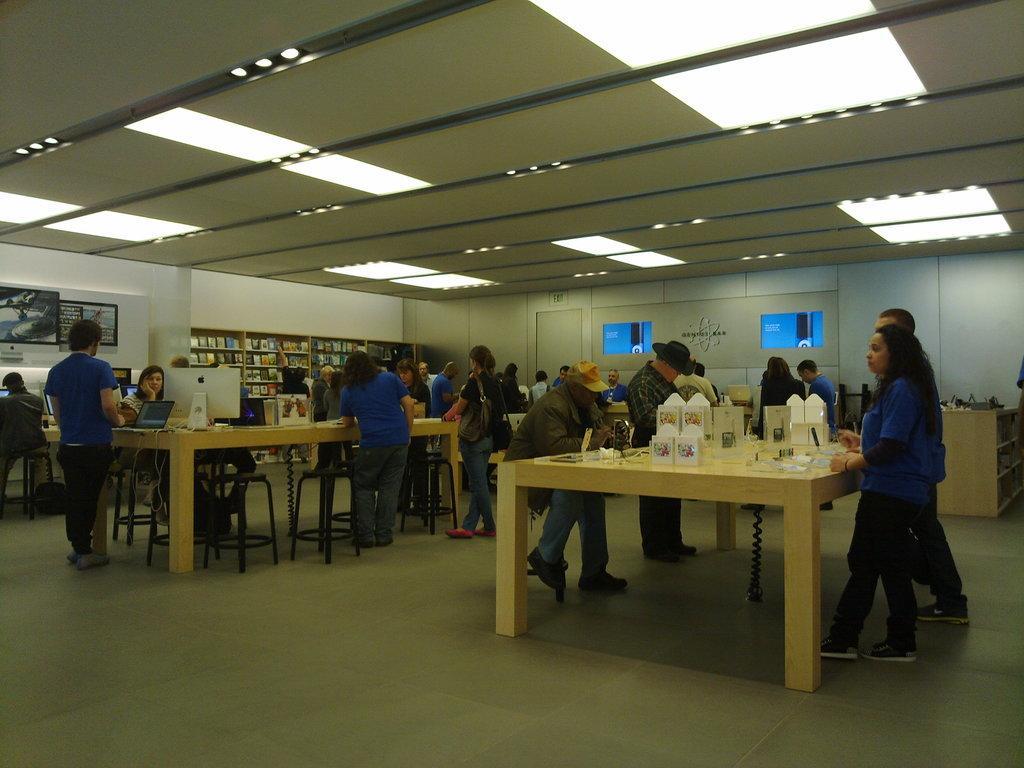Describe this image in one or two sentences. In the image we can see there are people who are standing and on the table there are boxes and a monitor, laptop. 